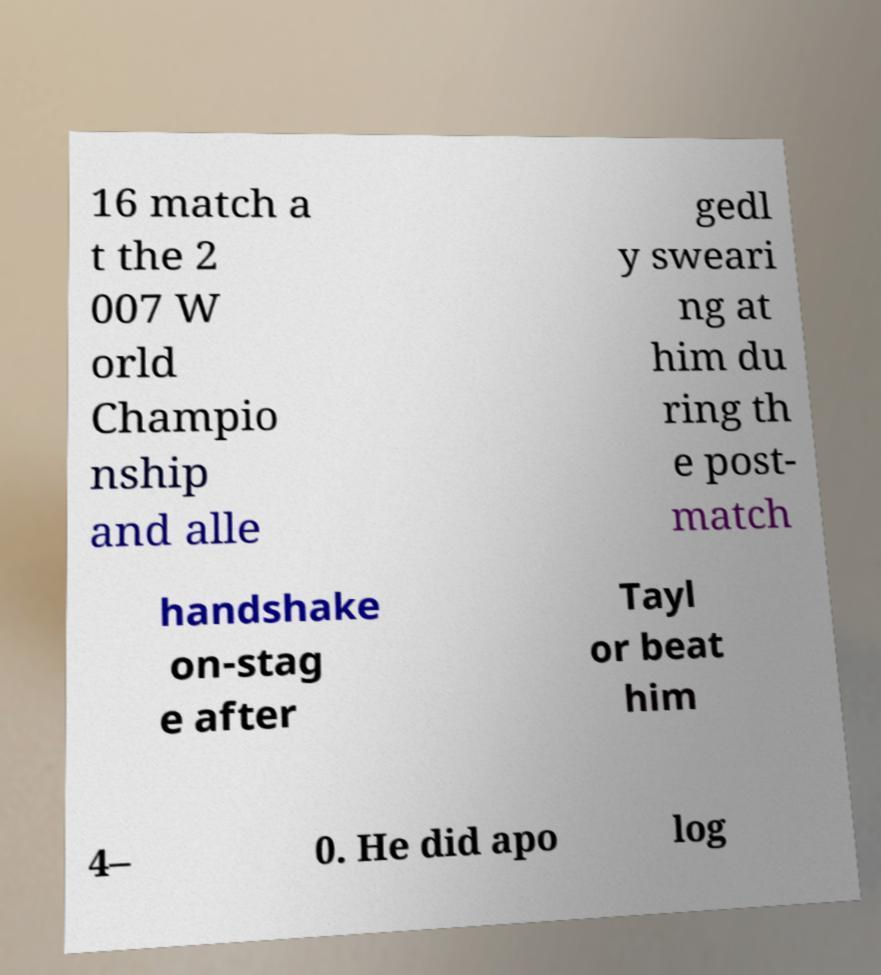Could you extract and type out the text from this image? 16 match a t the 2 007 W orld Champio nship and alle gedl y sweari ng at him du ring th e post- match handshake on-stag e after Tayl or beat him 4– 0. He did apo log 